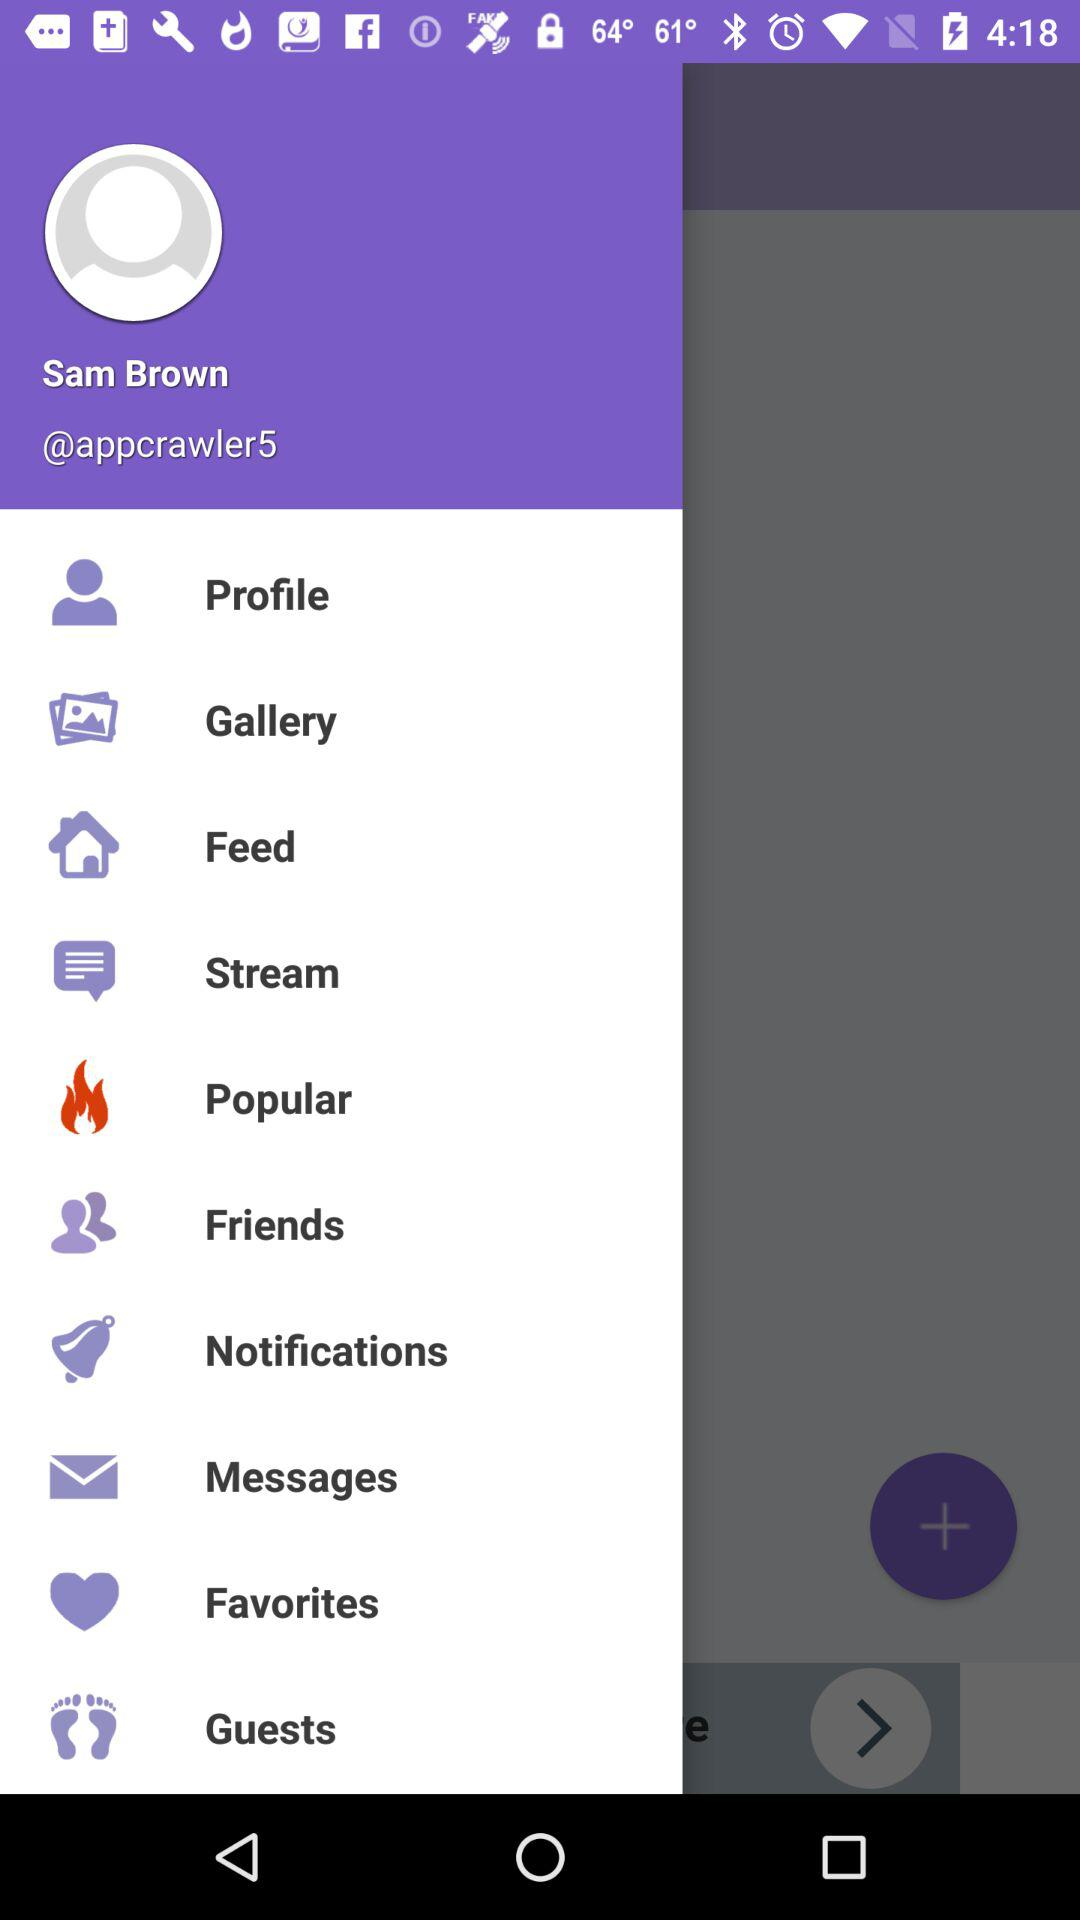What is the user name? The user name is Sam Brown. 